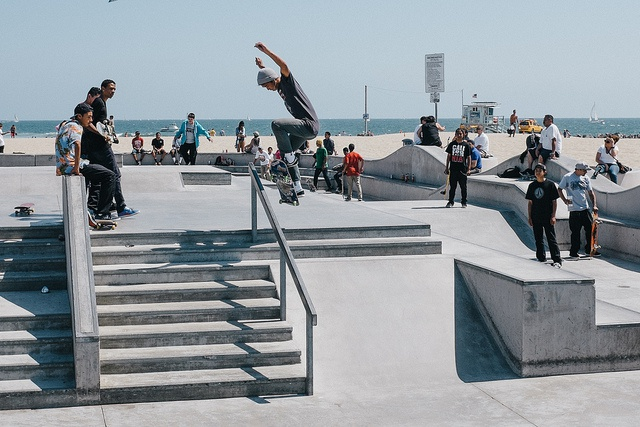Describe the objects in this image and their specific colors. I can see people in lightblue, black, gray, darkgray, and lightgray tones, people in lightblue, black, gray, darkgray, and maroon tones, people in lightblue, black, gray, and darkgray tones, people in lightblue, black, gray, maroon, and blue tones, and people in lightblue, black, gray, darkgray, and lightgray tones in this image. 